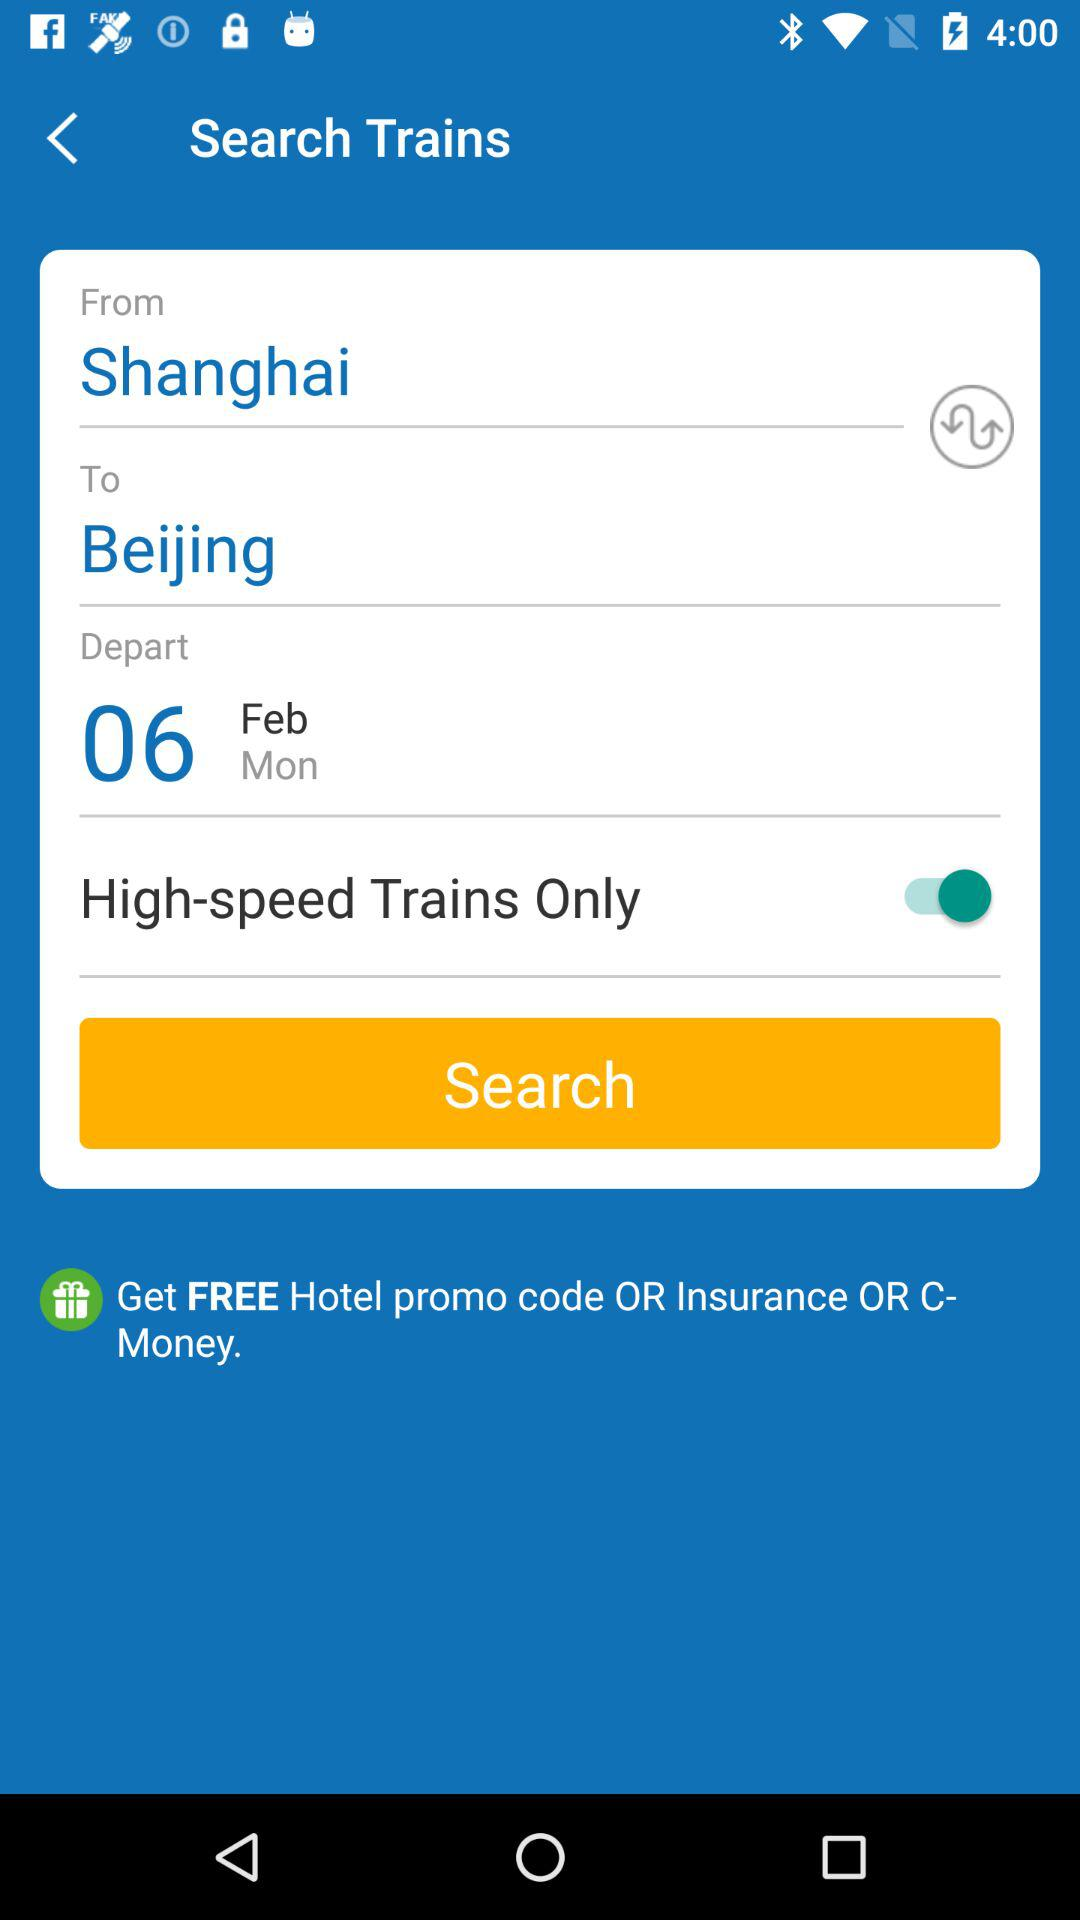How many cities are there in the search?
Answer the question using a single word or phrase. 2 